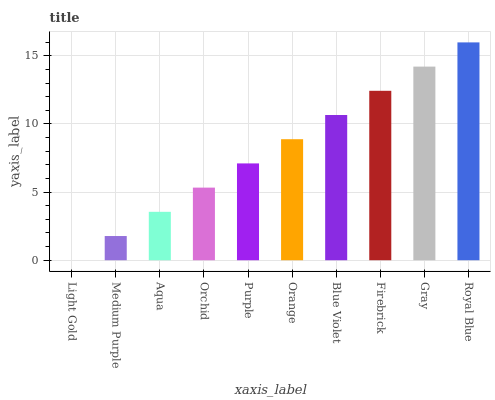Is Light Gold the minimum?
Answer yes or no. Yes. Is Royal Blue the maximum?
Answer yes or no. Yes. Is Medium Purple the minimum?
Answer yes or no. No. Is Medium Purple the maximum?
Answer yes or no. No. Is Medium Purple greater than Light Gold?
Answer yes or no. Yes. Is Light Gold less than Medium Purple?
Answer yes or no. Yes. Is Light Gold greater than Medium Purple?
Answer yes or no. No. Is Medium Purple less than Light Gold?
Answer yes or no. No. Is Orange the high median?
Answer yes or no. Yes. Is Purple the low median?
Answer yes or no. Yes. Is Blue Violet the high median?
Answer yes or no. No. Is Gray the low median?
Answer yes or no. No. 